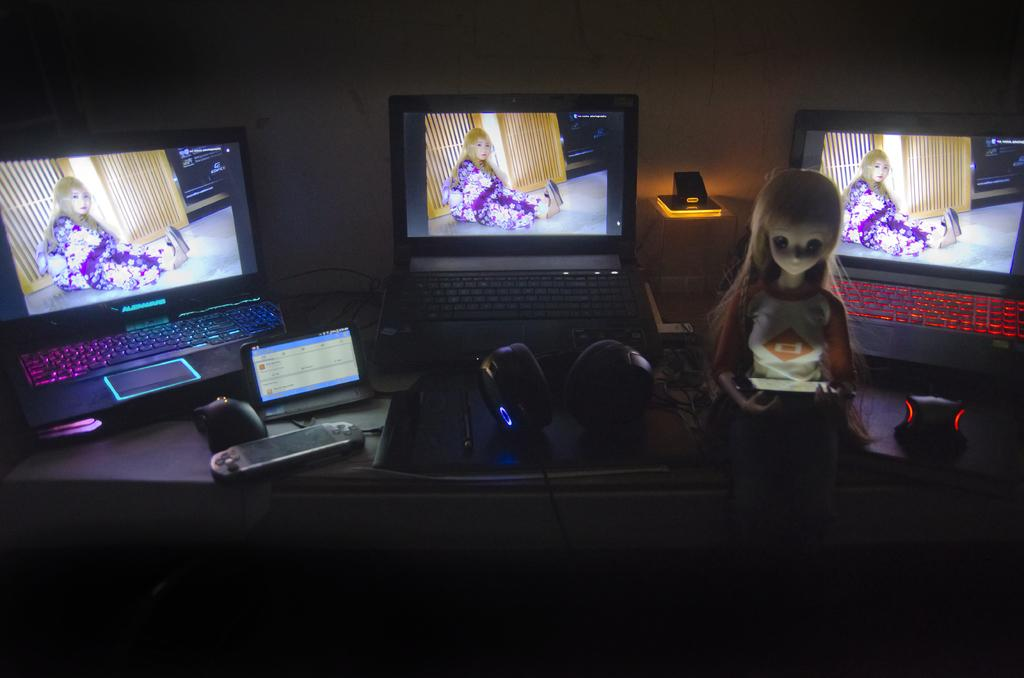What is the main piece of furniture in the image? There is a table in the image. What electronic devices are on the table? There are laptops on the table. What other objects can be seen on the table? There is a remote, mouses, a tab, a toy, and a wall in the background of the image. What type of veil is draped over the laptops in the image? There is no veil present in the image; it features a table with various objects on it. What offer is being made by the toy in the image? The toy does not make any offer in the image; it is simply a toy among other objects on the table. 